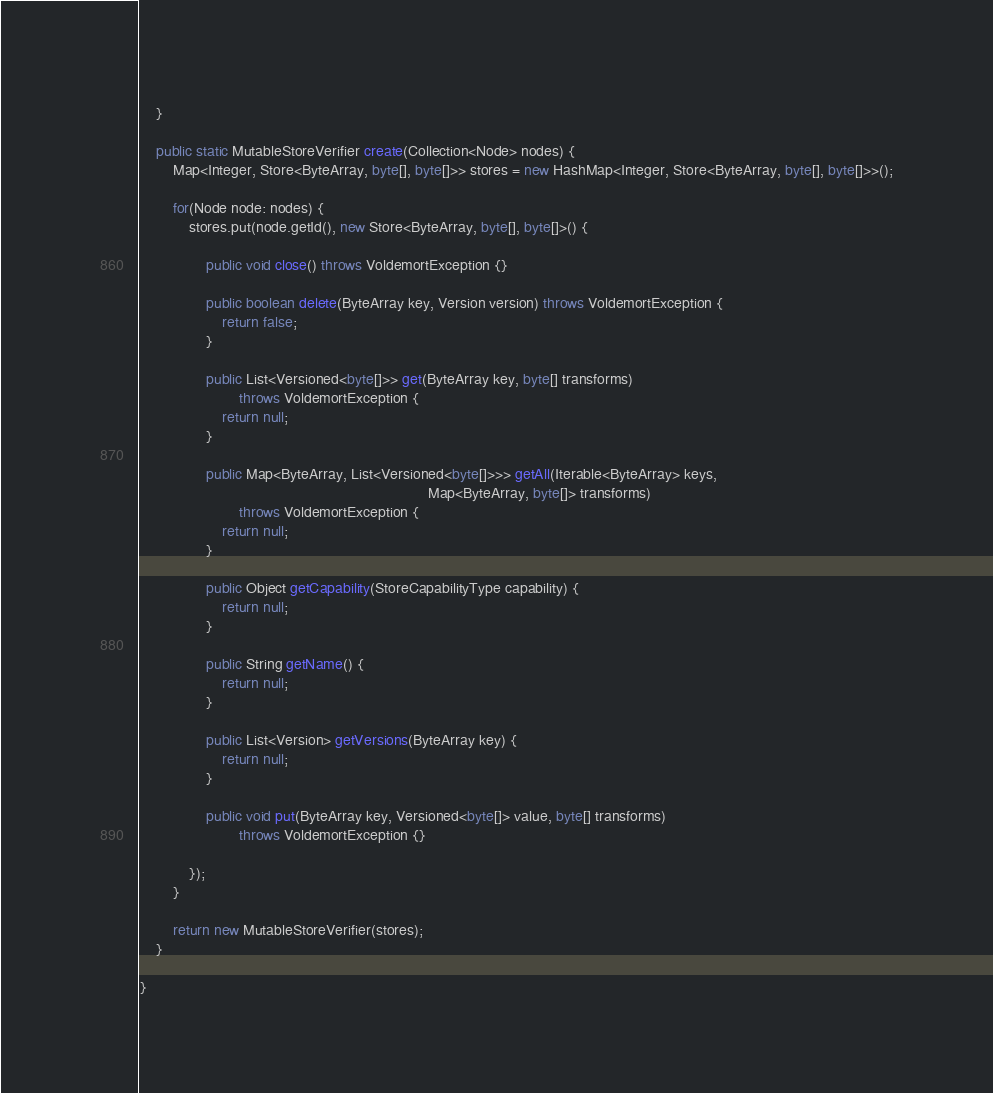<code> <loc_0><loc_0><loc_500><loc_500><_Java_>    }

    public static MutableStoreVerifier create(Collection<Node> nodes) {
        Map<Integer, Store<ByteArray, byte[], byte[]>> stores = new HashMap<Integer, Store<ByteArray, byte[], byte[]>>();

        for(Node node: nodes) {
            stores.put(node.getId(), new Store<ByteArray, byte[], byte[]>() {

                public void close() throws VoldemortException {}

                public boolean delete(ByteArray key, Version version) throws VoldemortException {
                    return false;
                }

                public List<Versioned<byte[]>> get(ByteArray key, byte[] transforms)
                        throws VoldemortException {
                    return null;
                }

                public Map<ByteArray, List<Versioned<byte[]>>> getAll(Iterable<ByteArray> keys,
                                                                      Map<ByteArray, byte[]> transforms)
                        throws VoldemortException {
                    return null;
                }

                public Object getCapability(StoreCapabilityType capability) {
                    return null;
                }

                public String getName() {
                    return null;
                }

                public List<Version> getVersions(ByteArray key) {
                    return null;
                }

                public void put(ByteArray key, Versioned<byte[]> value, byte[] transforms)
                        throws VoldemortException {}

            });
        }

        return new MutableStoreVerifier(stores);
    }

}
</code> 